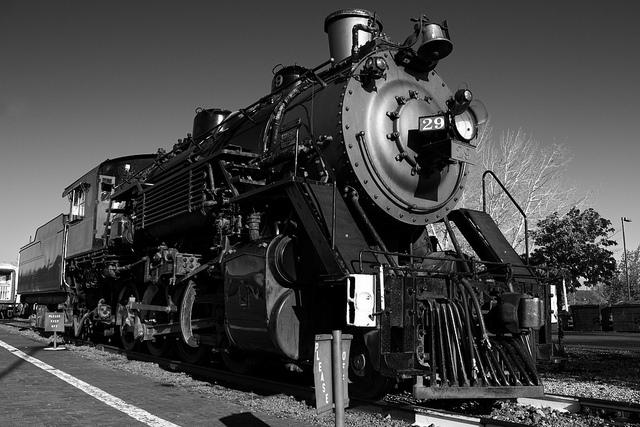Is this a modern train?
Quick response, please. No. What number is on the train?
Give a very brief answer. 29. Is this picture in color?
Concise answer only. No. What type of transportation is shown?
Give a very brief answer. Train. 